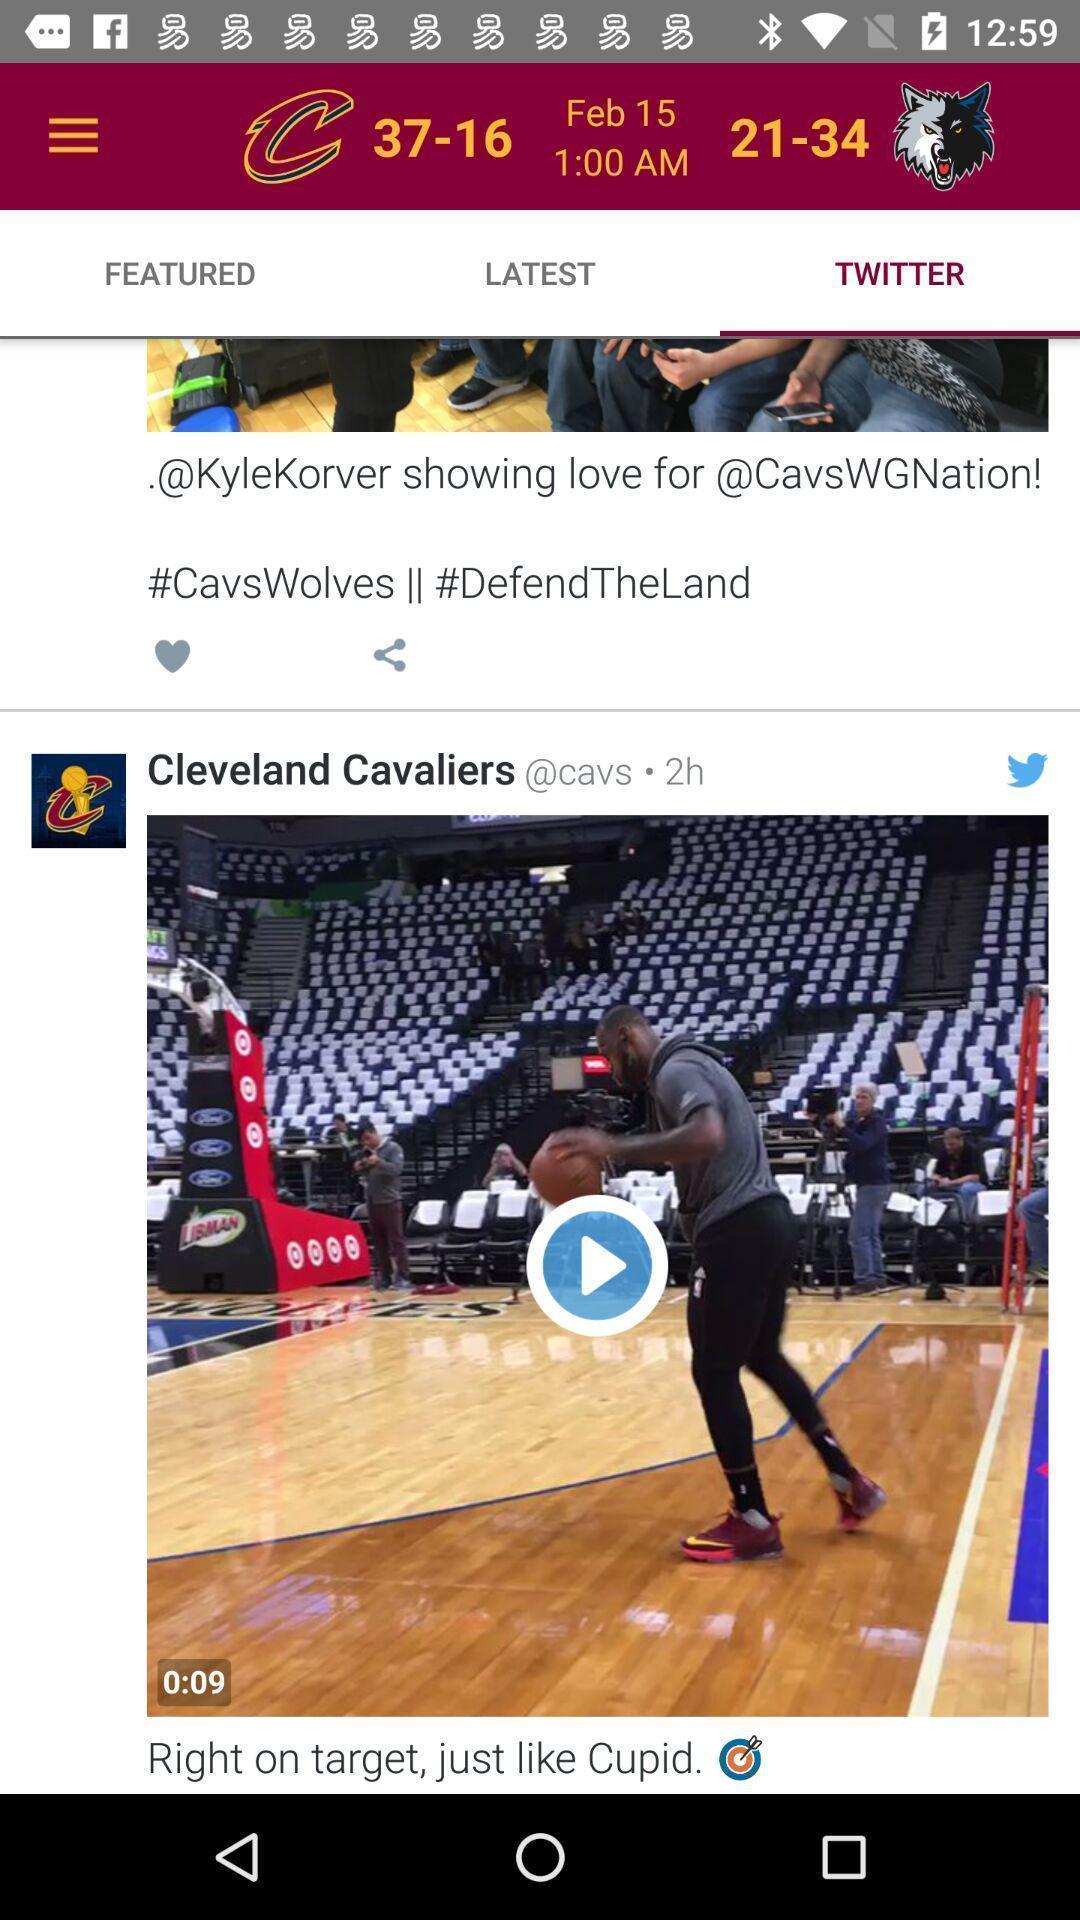Provide a detailed account of this screenshot. Video clips in the application with some options. 